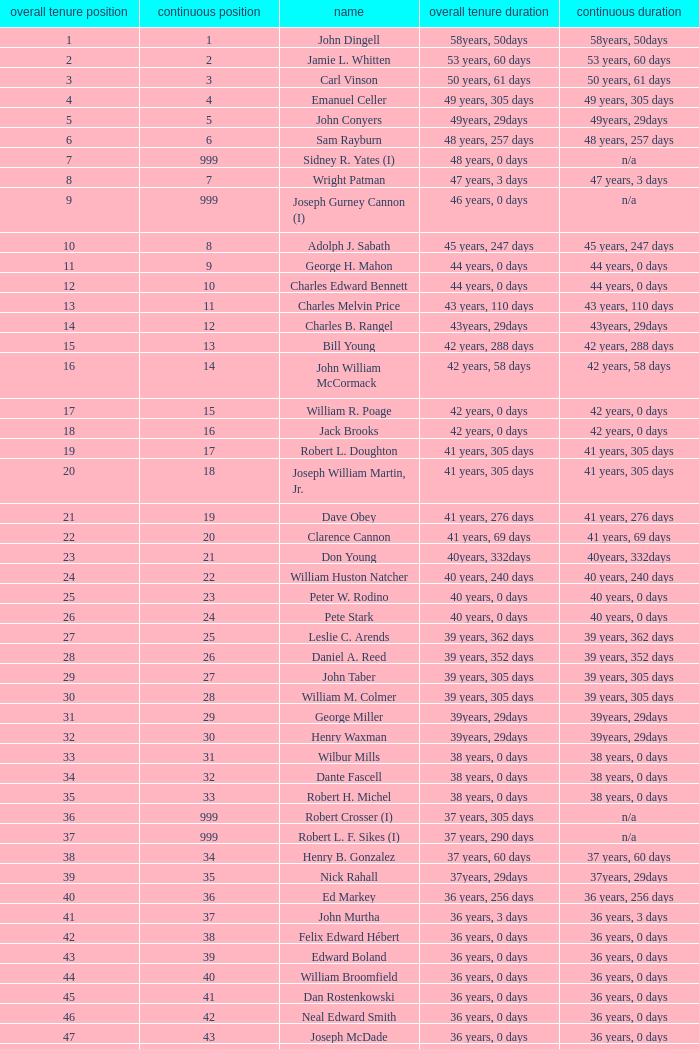How many uninterrupted ranks does john dingell have? 1.0. 